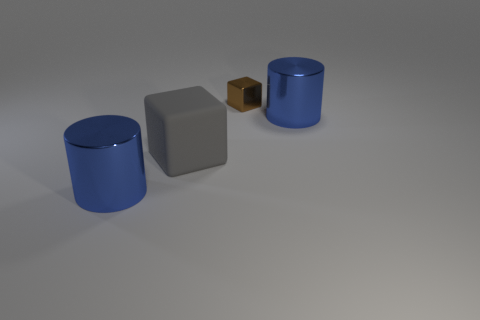Add 1 shiny cylinders. How many objects exist? 5 Add 2 balls. How many balls exist? 2 Subtract 0 cyan cubes. How many objects are left? 4 Subtract all brown things. Subtract all big cylinders. How many objects are left? 1 Add 2 large blue cylinders. How many large blue cylinders are left? 4 